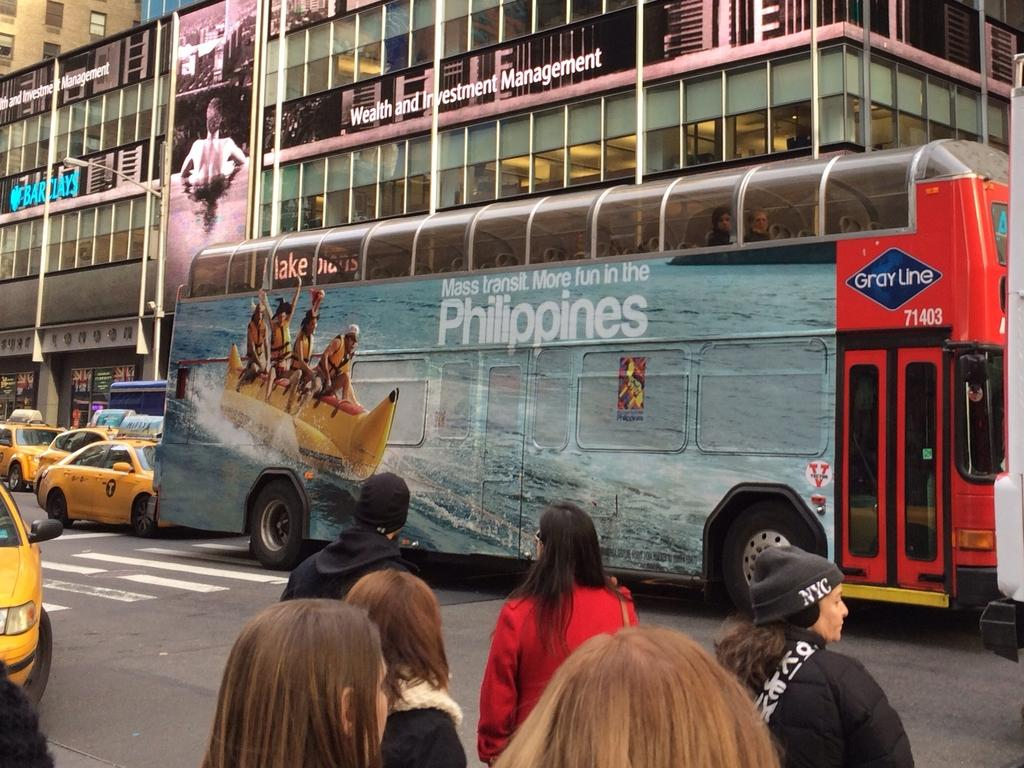<image>
Offer a succinct explanation of the picture presented. A large bus with Philippines on the side is on a road. 